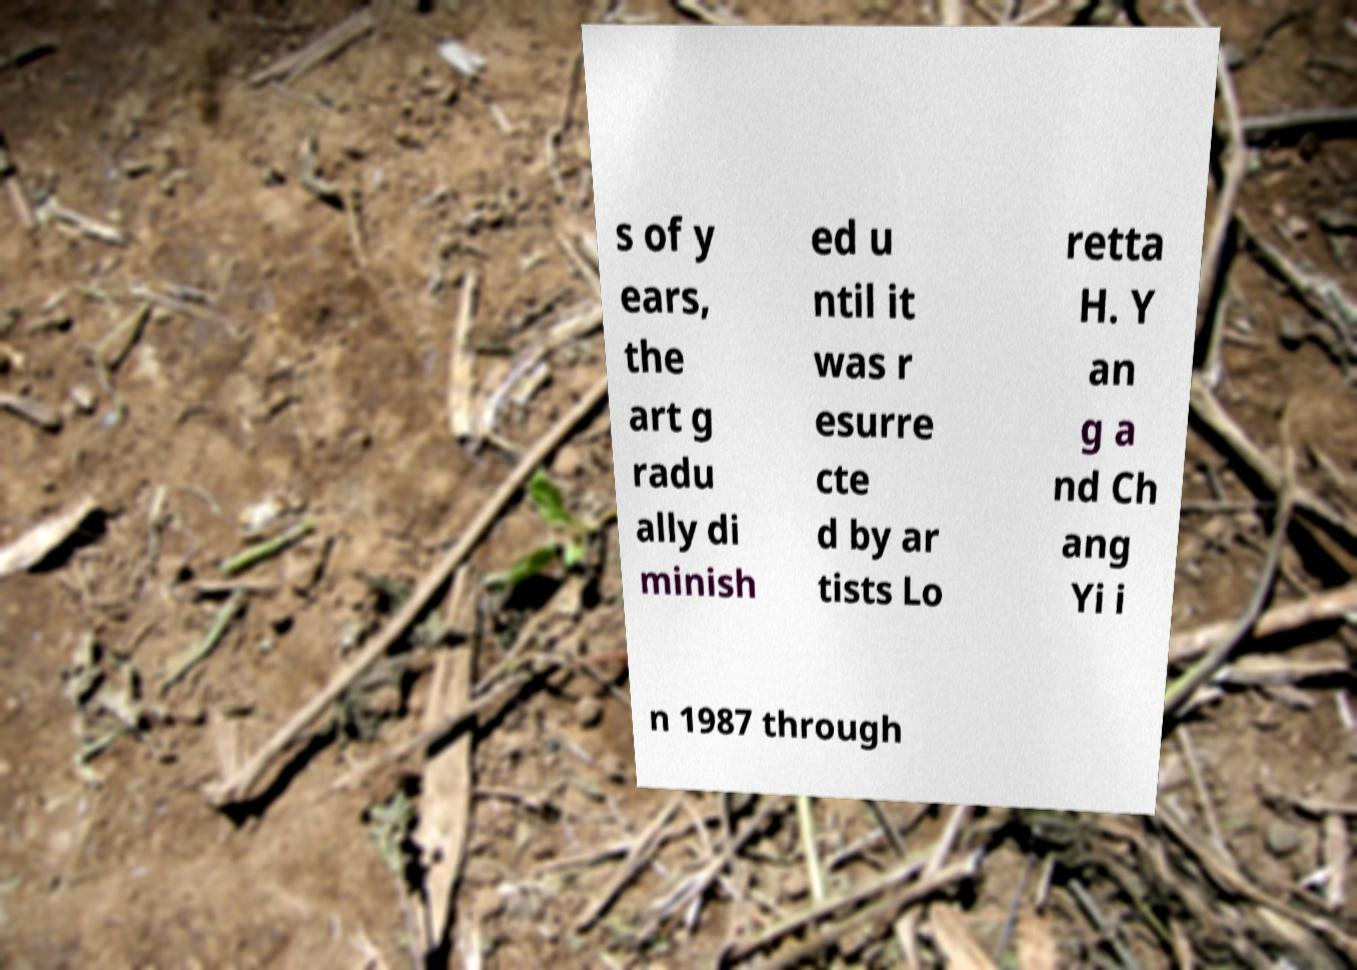Can you read and provide the text displayed in the image?This photo seems to have some interesting text. Can you extract and type it out for me? s of y ears, the art g radu ally di minish ed u ntil it was r esurre cte d by ar tists Lo retta H. Y an g a nd Ch ang Yi i n 1987 through 